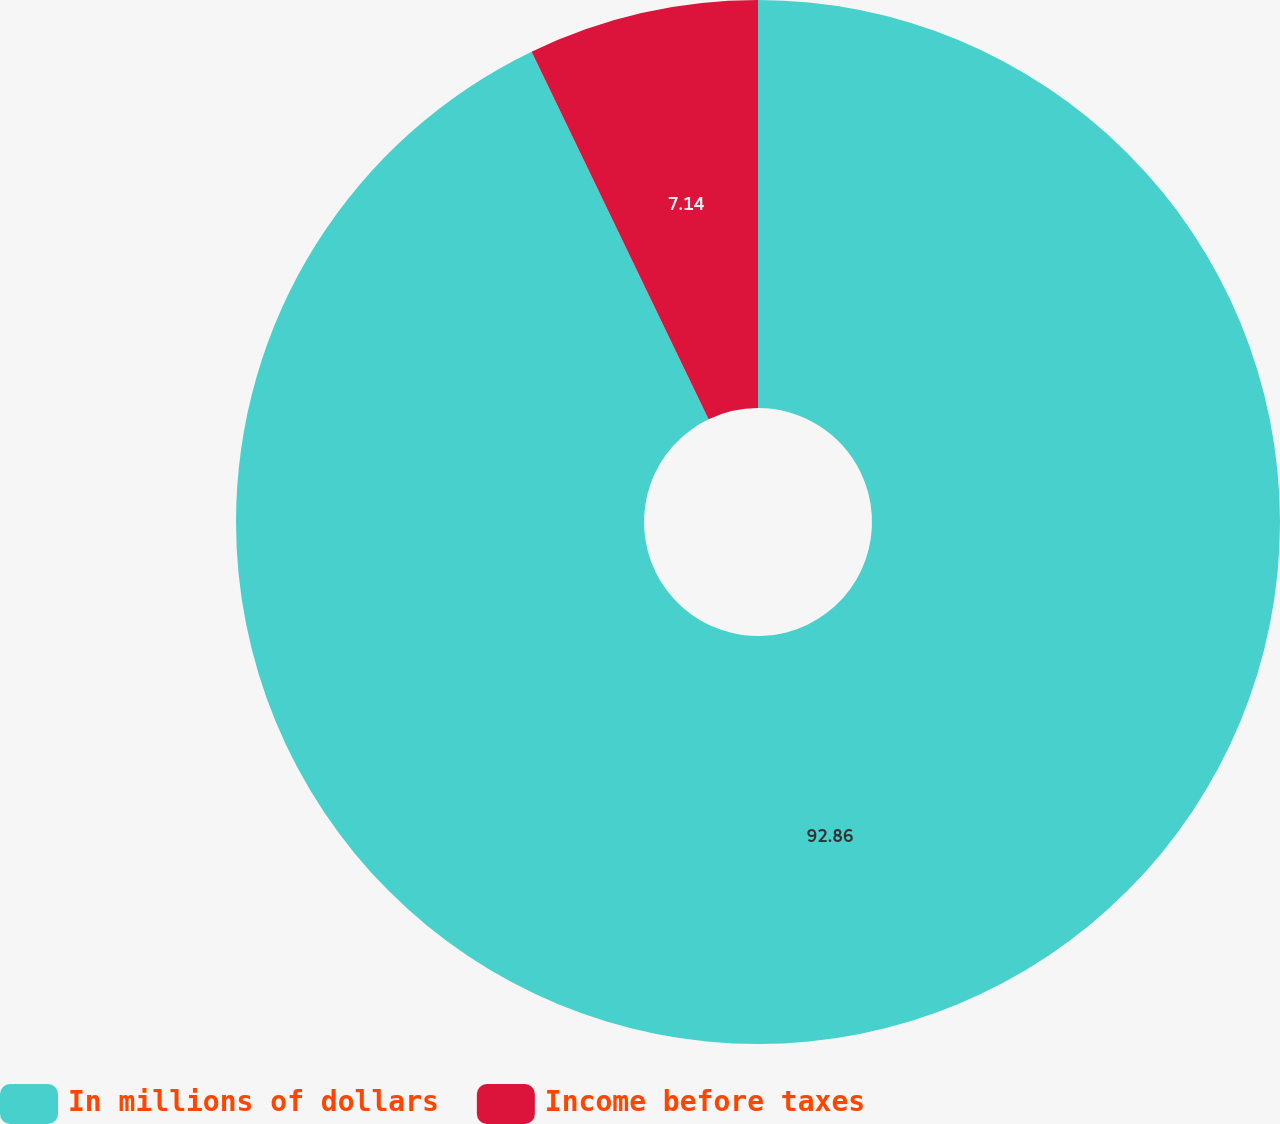Convert chart to OTSL. <chart><loc_0><loc_0><loc_500><loc_500><pie_chart><fcel>In millions of dollars<fcel>Income before taxes<nl><fcel>92.86%<fcel>7.14%<nl></chart> 